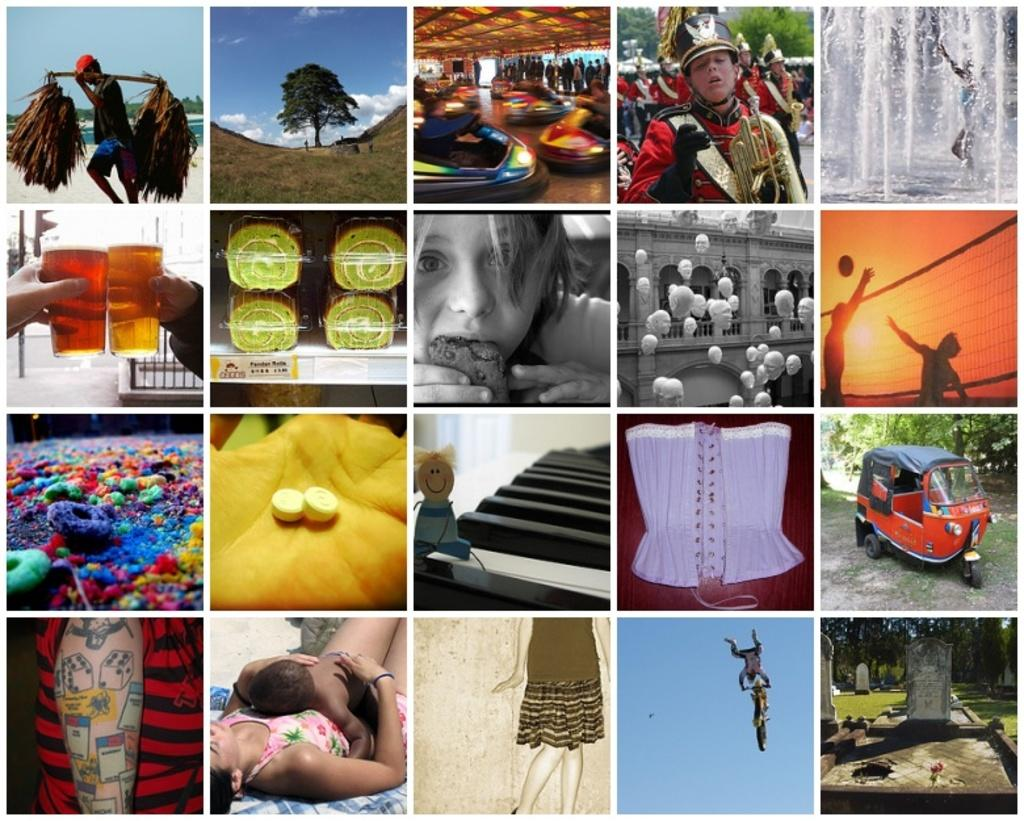What is the main subject of the image? There is a man standing in the image. What else can be seen in the image besides the man? There is a plant, two human hands, a glass on the right side, a vehicle, and two persons lying down in the image. What type of wound can be seen on the plant in the image? There is no wound present on the plant in the image; it appears to be a healthy plant. 